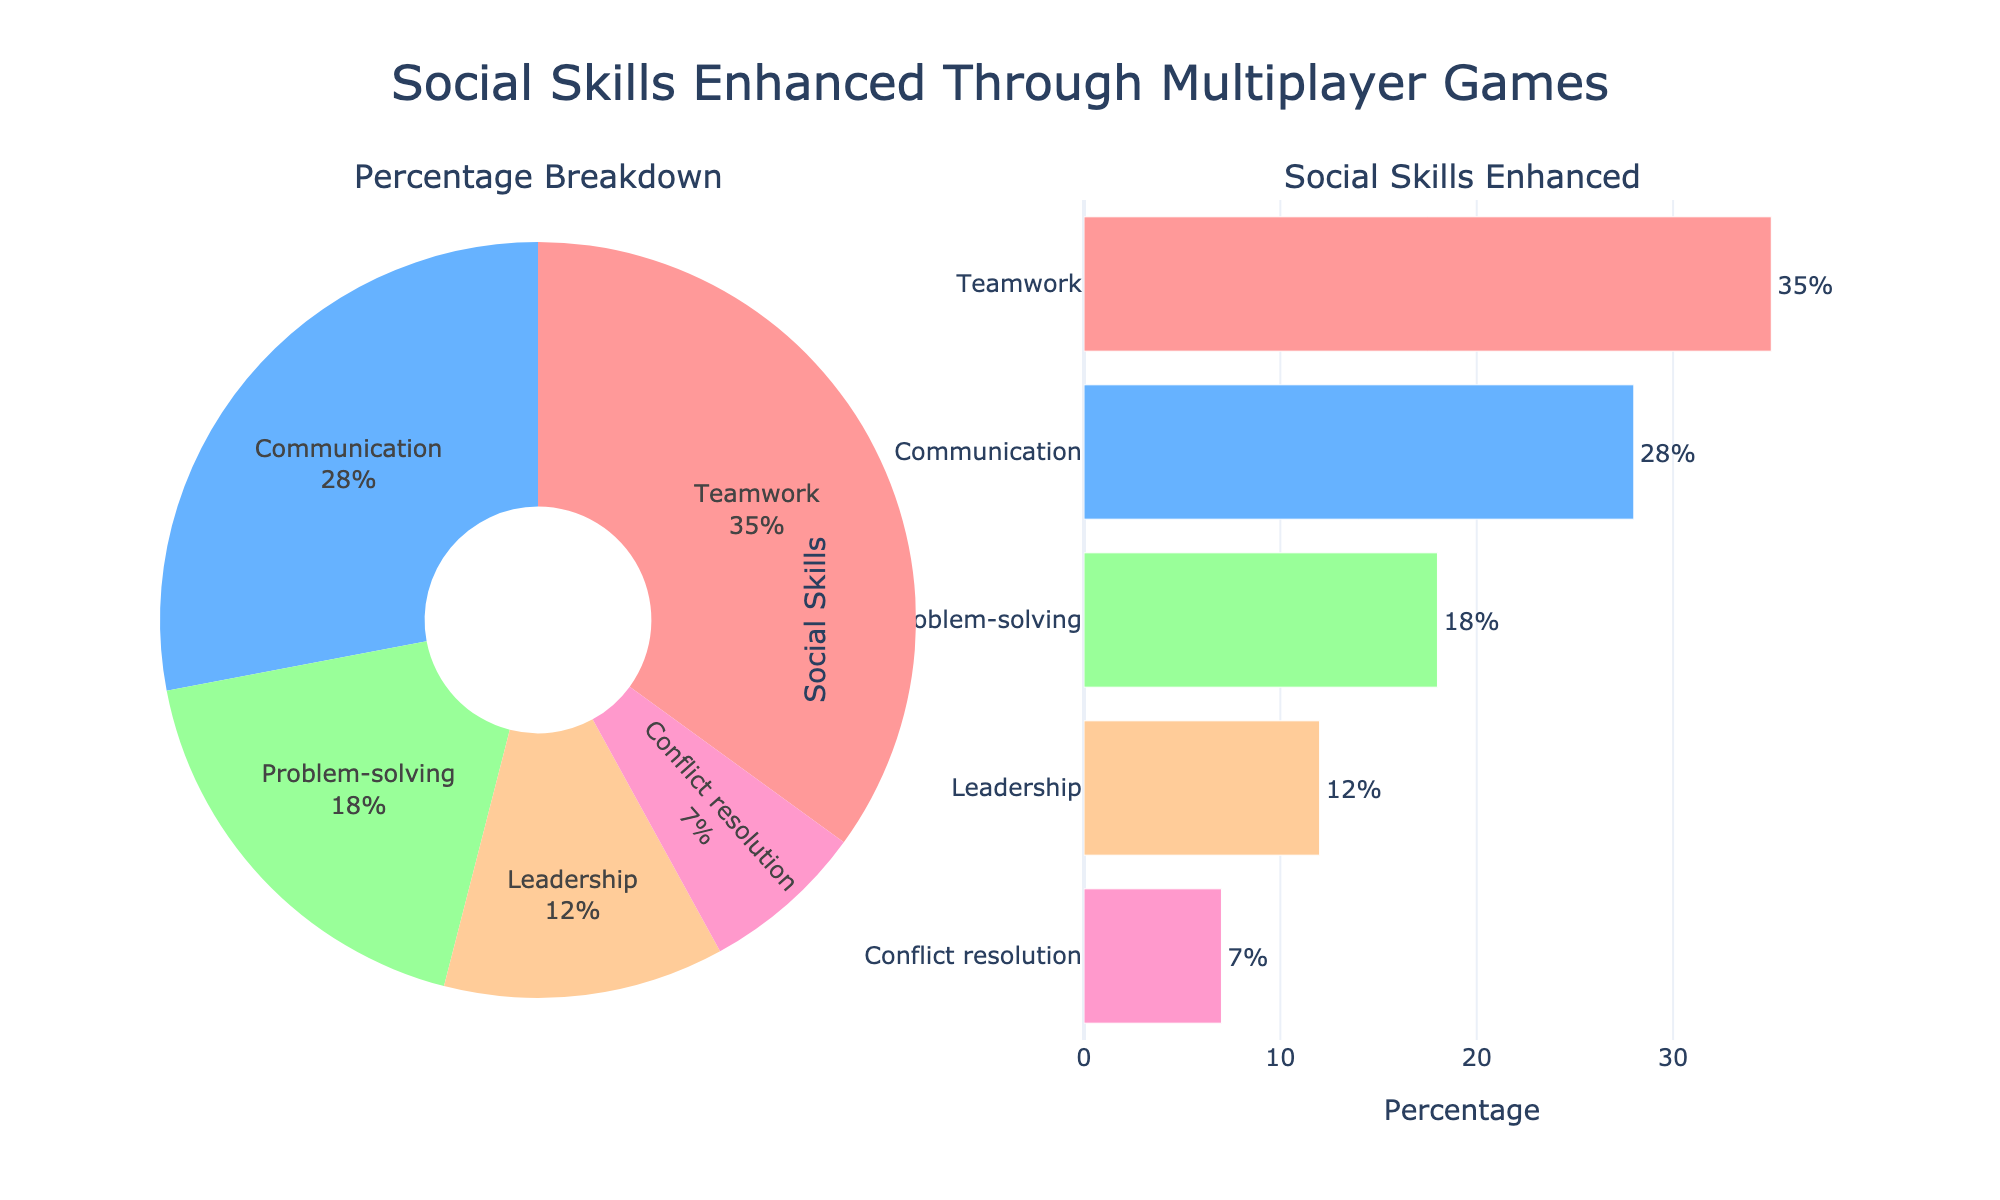what is the title of the figure? The title is located at the top center of the figure and it represents the main theme of the plots.
Answer: Social Skills Enhanced Through Multiplayer Games What social skill has the highest percentage? From both the pie and bar charts, Teamwork has the largest portion visible, making it the highest percentage.
Answer: Teamwork What is the combined percentage of Leadership and Conflict resolution? To find the combined percentage, sum the values for Leadership and Conflict resolution: 12% + 7%.
Answer: 19% Which social skill ranks second in terms of percentage? By looking at both the pie chart and the bar chart, Communication has the second largest share after Teamwork.
Answer: Communication How much more percentage does Teamwork have compared to Problem-solving? Subtract the percentage of Problem-solving from Teamwork: 35% - 18%.
Answer: 17% What is the percentage difference between the highest and lowest social skills? The highest percentage is Teamwork at 35%, and the lowest is Conflict resolution at 7%. The difference is 35% - 7%.
Answer: 28% Which two social skills have a total percentage closest to 30%? The pair of social skills we should look at for the closest total to 30% are Communication (28%) and Conflict resolution (7%), but this exceeds 30%. The correct closest pair without exceeding is Problem-solving (18%) and Leadership (12%).
Answer: Problem-solving and Leadership What percentage represents the three least-ranked social skills together? Summing the percentages of Problem-solving, Leadership, and Conflict resolution: 18% + 12% + 7%.
Answer: 37% What color represents Communication in the bar chart? In the bar chart, Communication is represented by the second color from the top, which appears light blue.
Answer: Light blue What is the unique visual feature of the pie chart? The pie chart has a noticeable hole in the center, indicating that it is a donut chart.
Answer: It has a hole (donut style) 